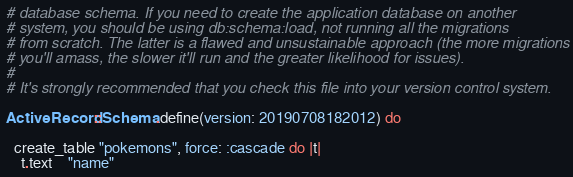Convert code to text. <code><loc_0><loc_0><loc_500><loc_500><_Ruby_># database schema. If you need to create the application database on another
# system, you should be using db:schema:load, not running all the migrations
# from scratch. The latter is a flawed and unsustainable approach (the more migrations
# you'll amass, the slower it'll run and the greater likelihood for issues).
#
# It's strongly recommended that you check this file into your version control system.

ActiveRecord::Schema.define(version: 20190708182012) do

  create_table "pokemons", force: :cascade do |t|
    t.text    "name"</code> 